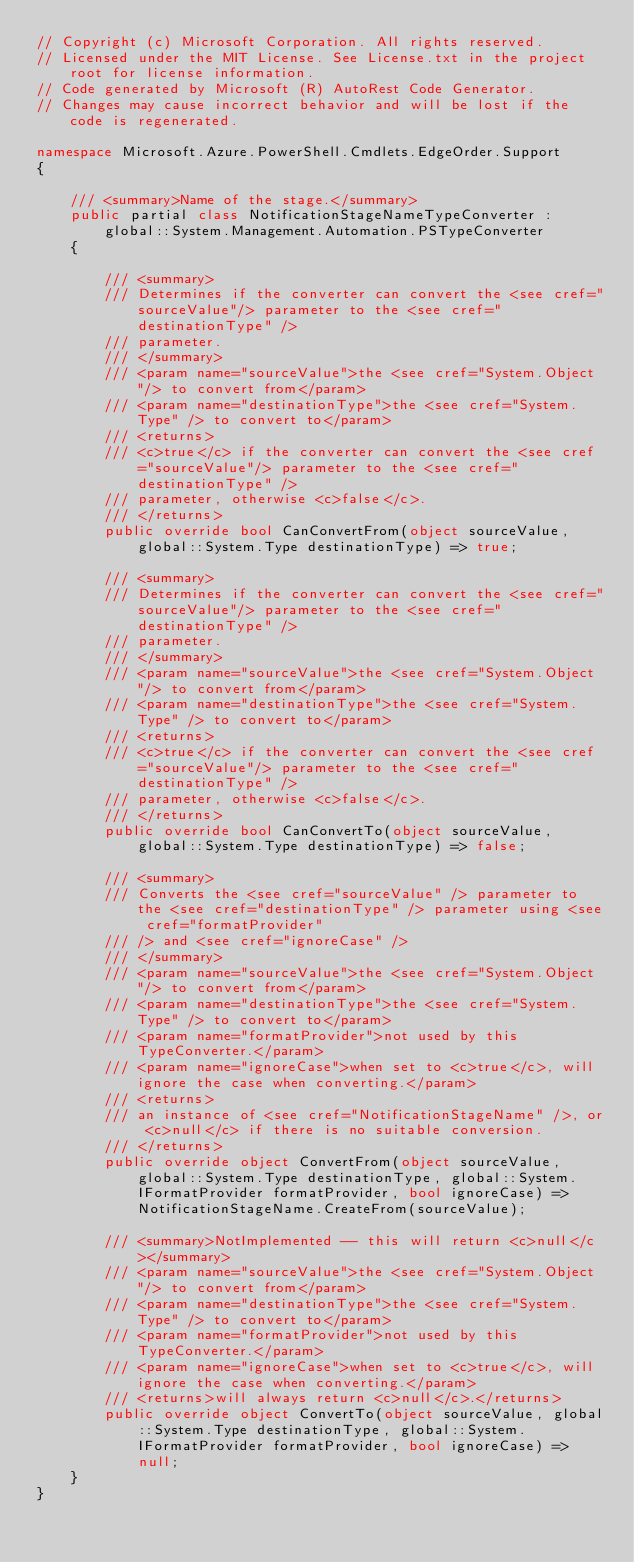Convert code to text. <code><loc_0><loc_0><loc_500><loc_500><_C#_>// Copyright (c) Microsoft Corporation. All rights reserved.
// Licensed under the MIT License. See License.txt in the project root for license information.
// Code generated by Microsoft (R) AutoRest Code Generator.
// Changes may cause incorrect behavior and will be lost if the code is regenerated.

namespace Microsoft.Azure.PowerShell.Cmdlets.EdgeOrder.Support
{

    /// <summary>Name of the stage.</summary>
    public partial class NotificationStageNameTypeConverter :
        global::System.Management.Automation.PSTypeConverter
    {

        /// <summary>
        /// Determines if the converter can convert the <see cref="sourceValue"/> parameter to the <see cref="destinationType" />
        /// parameter.
        /// </summary>
        /// <param name="sourceValue">the <see cref="System.Object"/> to convert from</param>
        /// <param name="destinationType">the <see cref="System.Type" /> to convert to</param>
        /// <returns>
        /// <c>true</c> if the converter can convert the <see cref="sourceValue"/> parameter to the <see cref="destinationType" />
        /// parameter, otherwise <c>false</c>.
        /// </returns>
        public override bool CanConvertFrom(object sourceValue, global::System.Type destinationType) => true;

        /// <summary>
        /// Determines if the converter can convert the <see cref="sourceValue"/> parameter to the <see cref="destinationType" />
        /// parameter.
        /// </summary>
        /// <param name="sourceValue">the <see cref="System.Object"/> to convert from</param>
        /// <param name="destinationType">the <see cref="System.Type" /> to convert to</param>
        /// <returns>
        /// <c>true</c> if the converter can convert the <see cref="sourceValue"/> parameter to the <see cref="destinationType" />
        /// parameter, otherwise <c>false</c>.
        /// </returns>
        public override bool CanConvertTo(object sourceValue, global::System.Type destinationType) => false;

        /// <summary>
        /// Converts the <see cref="sourceValue" /> parameter to the <see cref="destinationType" /> parameter using <see cref="formatProvider"
        /// /> and <see cref="ignoreCase" />
        /// </summary>
        /// <param name="sourceValue">the <see cref="System.Object"/> to convert from</param>
        /// <param name="destinationType">the <see cref="System.Type" /> to convert to</param>
        /// <param name="formatProvider">not used by this TypeConverter.</param>
        /// <param name="ignoreCase">when set to <c>true</c>, will ignore the case when converting.</param>
        /// <returns>
        /// an instance of <see cref="NotificationStageName" />, or <c>null</c> if there is no suitable conversion.
        /// </returns>
        public override object ConvertFrom(object sourceValue, global::System.Type destinationType, global::System.IFormatProvider formatProvider, bool ignoreCase) => NotificationStageName.CreateFrom(sourceValue);

        /// <summary>NotImplemented -- this will return <c>null</c></summary>
        /// <param name="sourceValue">the <see cref="System.Object"/> to convert from</param>
        /// <param name="destinationType">the <see cref="System.Type" /> to convert to</param>
        /// <param name="formatProvider">not used by this TypeConverter.</param>
        /// <param name="ignoreCase">when set to <c>true</c>, will ignore the case when converting.</param>
        /// <returns>will always return <c>null</c>.</returns>
        public override object ConvertTo(object sourceValue, global::System.Type destinationType, global::System.IFormatProvider formatProvider, bool ignoreCase) => null;
    }
}</code> 